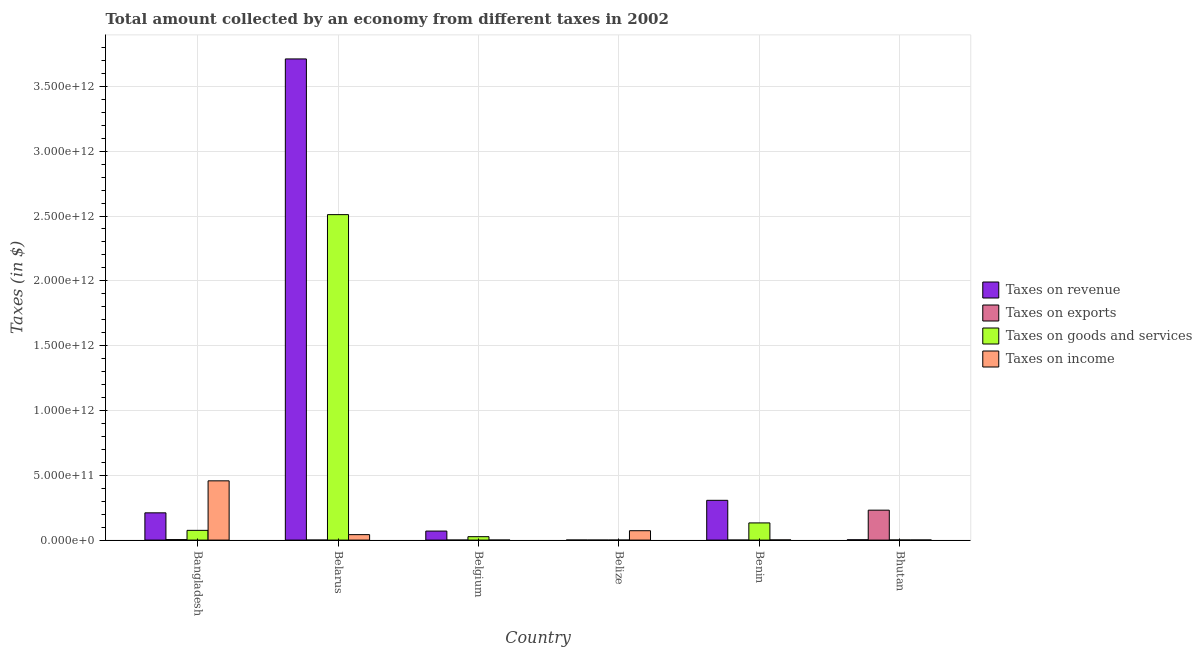How many different coloured bars are there?
Your answer should be compact. 4. How many groups of bars are there?
Give a very brief answer. 6. Are the number of bars per tick equal to the number of legend labels?
Make the answer very short. Yes. How many bars are there on the 2nd tick from the left?
Offer a very short reply. 4. What is the label of the 5th group of bars from the left?
Make the answer very short. Benin. What is the amount collected as tax on revenue in Belgium?
Your answer should be very brief. 6.97e+1. Across all countries, what is the maximum amount collected as tax on exports?
Keep it short and to the point. 2.31e+11. Across all countries, what is the minimum amount collected as tax on income?
Offer a very short reply. 7.89e+07. In which country was the amount collected as tax on exports maximum?
Your response must be concise. Bhutan. In which country was the amount collected as tax on income minimum?
Your answer should be very brief. Belgium. What is the total amount collected as tax on revenue in the graph?
Offer a very short reply. 4.30e+12. What is the difference between the amount collected as tax on revenue in Bangladesh and that in Belarus?
Your answer should be compact. -3.50e+12. What is the difference between the amount collected as tax on revenue in Belarus and the amount collected as tax on income in Belize?
Provide a short and direct response. 3.64e+12. What is the average amount collected as tax on exports per country?
Your response must be concise. 3.92e+1. What is the difference between the amount collected as tax on income and amount collected as tax on exports in Bhutan?
Provide a succinct answer. -2.30e+11. In how many countries, is the amount collected as tax on goods greater than 1500000000000 $?
Provide a short and direct response. 1. What is the ratio of the amount collected as tax on income in Belarus to that in Benin?
Offer a terse response. 32.37. Is the difference between the amount collected as tax on revenue in Belize and Bhutan greater than the difference between the amount collected as tax on goods in Belize and Bhutan?
Make the answer very short. No. What is the difference between the highest and the second highest amount collected as tax on income?
Provide a succinct answer. 3.85e+11. What is the difference between the highest and the lowest amount collected as tax on goods?
Make the answer very short. 2.51e+12. In how many countries, is the amount collected as tax on exports greater than the average amount collected as tax on exports taken over all countries?
Your response must be concise. 1. What does the 4th bar from the left in Benin represents?
Ensure brevity in your answer.  Taxes on income. What does the 1st bar from the right in Bangladesh represents?
Ensure brevity in your answer.  Taxes on income. Are all the bars in the graph horizontal?
Provide a succinct answer. No. What is the difference between two consecutive major ticks on the Y-axis?
Your answer should be very brief. 5.00e+11. Does the graph contain any zero values?
Your answer should be compact. No. How are the legend labels stacked?
Give a very brief answer. Vertical. What is the title of the graph?
Keep it short and to the point. Total amount collected by an economy from different taxes in 2002. What is the label or title of the Y-axis?
Your response must be concise. Taxes (in $). What is the Taxes (in $) of Taxes on revenue in Bangladesh?
Give a very brief answer. 2.10e+11. What is the Taxes (in $) in Taxes on exports in Bangladesh?
Offer a very short reply. 3.85e+09. What is the Taxes (in $) in Taxes on goods and services in Bangladesh?
Make the answer very short. 7.52e+1. What is the Taxes (in $) in Taxes on income in Bangladesh?
Give a very brief answer. 4.57e+11. What is the Taxes (in $) of Taxes on revenue in Belarus?
Provide a short and direct response. 3.71e+12. What is the Taxes (in $) of Taxes on exports in Belarus?
Make the answer very short. 2.68e+07. What is the Taxes (in $) in Taxes on goods and services in Belarus?
Your answer should be very brief. 2.51e+12. What is the Taxes (in $) of Taxes on income in Belarus?
Provide a short and direct response. 4.22e+1. What is the Taxes (in $) in Taxes on revenue in Belgium?
Provide a succinct answer. 6.97e+1. What is the Taxes (in $) of Taxes on exports in Belgium?
Your answer should be compact. 3.69e+07. What is the Taxes (in $) in Taxes on goods and services in Belgium?
Your answer should be compact. 2.63e+1. What is the Taxes (in $) in Taxes on income in Belgium?
Ensure brevity in your answer.  7.89e+07. What is the Taxes (in $) of Taxes on revenue in Belize?
Offer a very short reply. 3.60e+08. What is the Taxes (in $) of Taxes on exports in Belize?
Make the answer very short. 1.19e+06. What is the Taxes (in $) in Taxes on goods and services in Belize?
Make the answer very short. 1.14e+08. What is the Taxes (in $) in Taxes on income in Belize?
Keep it short and to the point. 7.25e+1. What is the Taxes (in $) of Taxes on revenue in Benin?
Your response must be concise. 3.07e+11. What is the Taxes (in $) of Taxes on exports in Benin?
Give a very brief answer. 6.36e+05. What is the Taxes (in $) in Taxes on goods and services in Benin?
Offer a terse response. 1.33e+11. What is the Taxes (in $) in Taxes on income in Benin?
Offer a very short reply. 1.31e+09. What is the Taxes (in $) of Taxes on revenue in Bhutan?
Give a very brief answer. 2.41e+09. What is the Taxes (in $) of Taxes on exports in Bhutan?
Offer a terse response. 2.31e+11. What is the Taxes (in $) in Taxes on goods and services in Bhutan?
Provide a succinct answer. 9.15e+08. What is the Taxes (in $) in Taxes on income in Bhutan?
Make the answer very short. 8.41e+08. Across all countries, what is the maximum Taxes (in $) of Taxes on revenue?
Your answer should be very brief. 3.71e+12. Across all countries, what is the maximum Taxes (in $) in Taxes on exports?
Give a very brief answer. 2.31e+11. Across all countries, what is the maximum Taxes (in $) of Taxes on goods and services?
Give a very brief answer. 2.51e+12. Across all countries, what is the maximum Taxes (in $) in Taxes on income?
Your answer should be very brief. 4.57e+11. Across all countries, what is the minimum Taxes (in $) in Taxes on revenue?
Give a very brief answer. 3.60e+08. Across all countries, what is the minimum Taxes (in $) in Taxes on exports?
Provide a succinct answer. 6.36e+05. Across all countries, what is the minimum Taxes (in $) in Taxes on goods and services?
Your response must be concise. 1.14e+08. Across all countries, what is the minimum Taxes (in $) in Taxes on income?
Offer a very short reply. 7.89e+07. What is the total Taxes (in $) of Taxes on revenue in the graph?
Make the answer very short. 4.30e+12. What is the total Taxes (in $) in Taxes on exports in the graph?
Provide a succinct answer. 2.35e+11. What is the total Taxes (in $) of Taxes on goods and services in the graph?
Make the answer very short. 2.75e+12. What is the total Taxes (in $) in Taxes on income in the graph?
Keep it short and to the point. 5.74e+11. What is the difference between the Taxes (in $) in Taxes on revenue in Bangladesh and that in Belarus?
Provide a short and direct response. -3.50e+12. What is the difference between the Taxes (in $) of Taxes on exports in Bangladesh and that in Belarus?
Give a very brief answer. 3.82e+09. What is the difference between the Taxes (in $) of Taxes on goods and services in Bangladesh and that in Belarus?
Your answer should be compact. -2.44e+12. What is the difference between the Taxes (in $) of Taxes on income in Bangladesh and that in Belarus?
Give a very brief answer. 4.15e+11. What is the difference between the Taxes (in $) of Taxes on revenue in Bangladesh and that in Belgium?
Provide a short and direct response. 1.41e+11. What is the difference between the Taxes (in $) of Taxes on exports in Bangladesh and that in Belgium?
Ensure brevity in your answer.  3.81e+09. What is the difference between the Taxes (in $) of Taxes on goods and services in Bangladesh and that in Belgium?
Keep it short and to the point. 4.89e+1. What is the difference between the Taxes (in $) in Taxes on income in Bangladesh and that in Belgium?
Give a very brief answer. 4.57e+11. What is the difference between the Taxes (in $) of Taxes on revenue in Bangladesh and that in Belize?
Ensure brevity in your answer.  2.10e+11. What is the difference between the Taxes (in $) in Taxes on exports in Bangladesh and that in Belize?
Offer a terse response. 3.85e+09. What is the difference between the Taxes (in $) in Taxes on goods and services in Bangladesh and that in Belize?
Keep it short and to the point. 7.51e+1. What is the difference between the Taxes (in $) of Taxes on income in Bangladesh and that in Belize?
Give a very brief answer. 3.85e+11. What is the difference between the Taxes (in $) of Taxes on revenue in Bangladesh and that in Benin?
Make the answer very short. -9.65e+1. What is the difference between the Taxes (in $) of Taxes on exports in Bangladesh and that in Benin?
Provide a succinct answer. 3.85e+09. What is the difference between the Taxes (in $) of Taxes on goods and services in Bangladesh and that in Benin?
Provide a short and direct response. -5.74e+1. What is the difference between the Taxes (in $) in Taxes on income in Bangladesh and that in Benin?
Give a very brief answer. 4.56e+11. What is the difference between the Taxes (in $) of Taxes on revenue in Bangladesh and that in Bhutan?
Your answer should be very brief. 2.08e+11. What is the difference between the Taxes (in $) in Taxes on exports in Bangladesh and that in Bhutan?
Your answer should be very brief. -2.27e+11. What is the difference between the Taxes (in $) in Taxes on goods and services in Bangladesh and that in Bhutan?
Provide a succinct answer. 7.43e+1. What is the difference between the Taxes (in $) of Taxes on income in Bangladesh and that in Bhutan?
Your answer should be compact. 4.56e+11. What is the difference between the Taxes (in $) in Taxes on revenue in Belarus and that in Belgium?
Keep it short and to the point. 3.64e+12. What is the difference between the Taxes (in $) of Taxes on exports in Belarus and that in Belgium?
Provide a succinct answer. -1.01e+07. What is the difference between the Taxes (in $) in Taxes on goods and services in Belarus and that in Belgium?
Keep it short and to the point. 2.48e+12. What is the difference between the Taxes (in $) of Taxes on income in Belarus and that in Belgium?
Your answer should be very brief. 4.22e+1. What is the difference between the Taxes (in $) of Taxes on revenue in Belarus and that in Belize?
Offer a very short reply. 3.71e+12. What is the difference between the Taxes (in $) of Taxes on exports in Belarus and that in Belize?
Ensure brevity in your answer.  2.56e+07. What is the difference between the Taxes (in $) in Taxes on goods and services in Belarus and that in Belize?
Your response must be concise. 2.51e+12. What is the difference between the Taxes (in $) in Taxes on income in Belarus and that in Belize?
Your response must be concise. -3.03e+1. What is the difference between the Taxes (in $) in Taxes on revenue in Belarus and that in Benin?
Your response must be concise. 3.41e+12. What is the difference between the Taxes (in $) of Taxes on exports in Belarus and that in Benin?
Offer a terse response. 2.62e+07. What is the difference between the Taxes (in $) of Taxes on goods and services in Belarus and that in Benin?
Offer a very short reply. 2.38e+12. What is the difference between the Taxes (in $) in Taxes on income in Belarus and that in Benin?
Provide a succinct answer. 4.09e+1. What is the difference between the Taxes (in $) of Taxes on revenue in Belarus and that in Bhutan?
Your answer should be compact. 3.71e+12. What is the difference between the Taxes (in $) in Taxes on exports in Belarus and that in Bhutan?
Your answer should be compact. -2.31e+11. What is the difference between the Taxes (in $) in Taxes on goods and services in Belarus and that in Bhutan?
Provide a short and direct response. 2.51e+12. What is the difference between the Taxes (in $) in Taxes on income in Belarus and that in Bhutan?
Provide a succinct answer. 4.14e+1. What is the difference between the Taxes (in $) in Taxes on revenue in Belgium and that in Belize?
Your answer should be very brief. 6.93e+1. What is the difference between the Taxes (in $) of Taxes on exports in Belgium and that in Belize?
Make the answer very short. 3.57e+07. What is the difference between the Taxes (in $) in Taxes on goods and services in Belgium and that in Belize?
Offer a very short reply. 2.62e+1. What is the difference between the Taxes (in $) of Taxes on income in Belgium and that in Belize?
Keep it short and to the point. -7.24e+1. What is the difference between the Taxes (in $) of Taxes on revenue in Belgium and that in Benin?
Your answer should be very brief. -2.37e+11. What is the difference between the Taxes (in $) in Taxes on exports in Belgium and that in Benin?
Give a very brief answer. 3.62e+07. What is the difference between the Taxes (in $) in Taxes on goods and services in Belgium and that in Benin?
Your response must be concise. -1.06e+11. What is the difference between the Taxes (in $) of Taxes on income in Belgium and that in Benin?
Provide a short and direct response. -1.23e+09. What is the difference between the Taxes (in $) in Taxes on revenue in Belgium and that in Bhutan?
Your response must be concise. 6.73e+1. What is the difference between the Taxes (in $) in Taxes on exports in Belgium and that in Bhutan?
Give a very brief answer. -2.31e+11. What is the difference between the Taxes (in $) in Taxes on goods and services in Belgium and that in Bhutan?
Provide a succinct answer. 2.54e+1. What is the difference between the Taxes (in $) of Taxes on income in Belgium and that in Bhutan?
Your answer should be very brief. -7.62e+08. What is the difference between the Taxes (in $) in Taxes on revenue in Belize and that in Benin?
Provide a short and direct response. -3.06e+11. What is the difference between the Taxes (in $) in Taxes on exports in Belize and that in Benin?
Provide a succinct answer. 5.54e+05. What is the difference between the Taxes (in $) of Taxes on goods and services in Belize and that in Benin?
Provide a short and direct response. -1.33e+11. What is the difference between the Taxes (in $) of Taxes on income in Belize and that in Benin?
Your answer should be very brief. 7.12e+1. What is the difference between the Taxes (in $) of Taxes on revenue in Belize and that in Bhutan?
Provide a short and direct response. -2.05e+09. What is the difference between the Taxes (in $) in Taxes on exports in Belize and that in Bhutan?
Ensure brevity in your answer.  -2.31e+11. What is the difference between the Taxes (in $) of Taxes on goods and services in Belize and that in Bhutan?
Your response must be concise. -8.01e+08. What is the difference between the Taxes (in $) of Taxes on income in Belize and that in Bhutan?
Your answer should be very brief. 7.17e+1. What is the difference between the Taxes (in $) of Taxes on revenue in Benin and that in Bhutan?
Give a very brief answer. 3.04e+11. What is the difference between the Taxes (in $) in Taxes on exports in Benin and that in Bhutan?
Give a very brief answer. -2.31e+11. What is the difference between the Taxes (in $) in Taxes on goods and services in Benin and that in Bhutan?
Your answer should be compact. 1.32e+11. What is the difference between the Taxes (in $) in Taxes on income in Benin and that in Bhutan?
Your answer should be very brief. 4.64e+08. What is the difference between the Taxes (in $) in Taxes on revenue in Bangladesh and the Taxes (in $) in Taxes on exports in Belarus?
Ensure brevity in your answer.  2.10e+11. What is the difference between the Taxes (in $) of Taxes on revenue in Bangladesh and the Taxes (in $) of Taxes on goods and services in Belarus?
Your response must be concise. -2.30e+12. What is the difference between the Taxes (in $) in Taxes on revenue in Bangladesh and the Taxes (in $) in Taxes on income in Belarus?
Your answer should be very brief. 1.68e+11. What is the difference between the Taxes (in $) of Taxes on exports in Bangladesh and the Taxes (in $) of Taxes on goods and services in Belarus?
Offer a terse response. -2.51e+12. What is the difference between the Taxes (in $) of Taxes on exports in Bangladesh and the Taxes (in $) of Taxes on income in Belarus?
Offer a very short reply. -3.84e+1. What is the difference between the Taxes (in $) of Taxes on goods and services in Bangladesh and the Taxes (in $) of Taxes on income in Belarus?
Offer a terse response. 3.30e+1. What is the difference between the Taxes (in $) in Taxes on revenue in Bangladesh and the Taxes (in $) in Taxes on exports in Belgium?
Give a very brief answer. 2.10e+11. What is the difference between the Taxes (in $) of Taxes on revenue in Bangladesh and the Taxes (in $) of Taxes on goods and services in Belgium?
Provide a short and direct response. 1.84e+11. What is the difference between the Taxes (in $) in Taxes on revenue in Bangladesh and the Taxes (in $) in Taxes on income in Belgium?
Provide a succinct answer. 2.10e+11. What is the difference between the Taxes (in $) in Taxes on exports in Bangladesh and the Taxes (in $) in Taxes on goods and services in Belgium?
Provide a short and direct response. -2.25e+1. What is the difference between the Taxes (in $) of Taxes on exports in Bangladesh and the Taxes (in $) of Taxes on income in Belgium?
Keep it short and to the point. 3.77e+09. What is the difference between the Taxes (in $) in Taxes on goods and services in Bangladesh and the Taxes (in $) in Taxes on income in Belgium?
Your answer should be compact. 7.51e+1. What is the difference between the Taxes (in $) of Taxes on revenue in Bangladesh and the Taxes (in $) of Taxes on exports in Belize?
Provide a short and direct response. 2.10e+11. What is the difference between the Taxes (in $) in Taxes on revenue in Bangladesh and the Taxes (in $) in Taxes on goods and services in Belize?
Make the answer very short. 2.10e+11. What is the difference between the Taxes (in $) in Taxes on revenue in Bangladesh and the Taxes (in $) in Taxes on income in Belize?
Offer a very short reply. 1.38e+11. What is the difference between the Taxes (in $) in Taxes on exports in Bangladesh and the Taxes (in $) in Taxes on goods and services in Belize?
Your response must be concise. 3.73e+09. What is the difference between the Taxes (in $) of Taxes on exports in Bangladesh and the Taxes (in $) of Taxes on income in Belize?
Give a very brief answer. -6.86e+1. What is the difference between the Taxes (in $) of Taxes on goods and services in Bangladesh and the Taxes (in $) of Taxes on income in Belize?
Your answer should be very brief. 2.73e+09. What is the difference between the Taxes (in $) in Taxes on revenue in Bangladesh and the Taxes (in $) in Taxes on exports in Benin?
Your response must be concise. 2.10e+11. What is the difference between the Taxes (in $) of Taxes on revenue in Bangladesh and the Taxes (in $) of Taxes on goods and services in Benin?
Give a very brief answer. 7.77e+1. What is the difference between the Taxes (in $) of Taxes on revenue in Bangladesh and the Taxes (in $) of Taxes on income in Benin?
Give a very brief answer. 2.09e+11. What is the difference between the Taxes (in $) of Taxes on exports in Bangladesh and the Taxes (in $) of Taxes on goods and services in Benin?
Offer a very short reply. -1.29e+11. What is the difference between the Taxes (in $) in Taxes on exports in Bangladesh and the Taxes (in $) in Taxes on income in Benin?
Your answer should be compact. 2.54e+09. What is the difference between the Taxes (in $) in Taxes on goods and services in Bangladesh and the Taxes (in $) in Taxes on income in Benin?
Offer a terse response. 7.39e+1. What is the difference between the Taxes (in $) of Taxes on revenue in Bangladesh and the Taxes (in $) of Taxes on exports in Bhutan?
Keep it short and to the point. -2.07e+1. What is the difference between the Taxes (in $) of Taxes on revenue in Bangladesh and the Taxes (in $) of Taxes on goods and services in Bhutan?
Keep it short and to the point. 2.09e+11. What is the difference between the Taxes (in $) in Taxes on revenue in Bangladesh and the Taxes (in $) in Taxes on income in Bhutan?
Give a very brief answer. 2.09e+11. What is the difference between the Taxes (in $) in Taxes on exports in Bangladesh and the Taxes (in $) in Taxes on goods and services in Bhutan?
Keep it short and to the point. 2.93e+09. What is the difference between the Taxes (in $) in Taxes on exports in Bangladesh and the Taxes (in $) in Taxes on income in Bhutan?
Make the answer very short. 3.01e+09. What is the difference between the Taxes (in $) of Taxes on goods and services in Bangladesh and the Taxes (in $) of Taxes on income in Bhutan?
Your response must be concise. 7.44e+1. What is the difference between the Taxes (in $) of Taxes on revenue in Belarus and the Taxes (in $) of Taxes on exports in Belgium?
Your response must be concise. 3.71e+12. What is the difference between the Taxes (in $) of Taxes on revenue in Belarus and the Taxes (in $) of Taxes on goods and services in Belgium?
Make the answer very short. 3.69e+12. What is the difference between the Taxes (in $) in Taxes on revenue in Belarus and the Taxes (in $) in Taxes on income in Belgium?
Keep it short and to the point. 3.71e+12. What is the difference between the Taxes (in $) of Taxes on exports in Belarus and the Taxes (in $) of Taxes on goods and services in Belgium?
Your response must be concise. -2.63e+1. What is the difference between the Taxes (in $) in Taxes on exports in Belarus and the Taxes (in $) in Taxes on income in Belgium?
Keep it short and to the point. -5.21e+07. What is the difference between the Taxes (in $) of Taxes on goods and services in Belarus and the Taxes (in $) of Taxes on income in Belgium?
Give a very brief answer. 2.51e+12. What is the difference between the Taxes (in $) in Taxes on revenue in Belarus and the Taxes (in $) in Taxes on exports in Belize?
Keep it short and to the point. 3.71e+12. What is the difference between the Taxes (in $) in Taxes on revenue in Belarus and the Taxes (in $) in Taxes on goods and services in Belize?
Provide a succinct answer. 3.71e+12. What is the difference between the Taxes (in $) in Taxes on revenue in Belarus and the Taxes (in $) in Taxes on income in Belize?
Provide a short and direct response. 3.64e+12. What is the difference between the Taxes (in $) of Taxes on exports in Belarus and the Taxes (in $) of Taxes on goods and services in Belize?
Your answer should be compact. -8.67e+07. What is the difference between the Taxes (in $) of Taxes on exports in Belarus and the Taxes (in $) of Taxes on income in Belize?
Your response must be concise. -7.25e+1. What is the difference between the Taxes (in $) in Taxes on goods and services in Belarus and the Taxes (in $) in Taxes on income in Belize?
Ensure brevity in your answer.  2.44e+12. What is the difference between the Taxes (in $) of Taxes on revenue in Belarus and the Taxes (in $) of Taxes on exports in Benin?
Your answer should be compact. 3.71e+12. What is the difference between the Taxes (in $) in Taxes on revenue in Belarus and the Taxes (in $) in Taxes on goods and services in Benin?
Your answer should be compact. 3.58e+12. What is the difference between the Taxes (in $) in Taxes on revenue in Belarus and the Taxes (in $) in Taxes on income in Benin?
Provide a short and direct response. 3.71e+12. What is the difference between the Taxes (in $) of Taxes on exports in Belarus and the Taxes (in $) of Taxes on goods and services in Benin?
Provide a succinct answer. -1.33e+11. What is the difference between the Taxes (in $) in Taxes on exports in Belarus and the Taxes (in $) in Taxes on income in Benin?
Ensure brevity in your answer.  -1.28e+09. What is the difference between the Taxes (in $) in Taxes on goods and services in Belarus and the Taxes (in $) in Taxes on income in Benin?
Provide a succinct answer. 2.51e+12. What is the difference between the Taxes (in $) of Taxes on revenue in Belarus and the Taxes (in $) of Taxes on exports in Bhutan?
Keep it short and to the point. 3.48e+12. What is the difference between the Taxes (in $) in Taxes on revenue in Belarus and the Taxes (in $) in Taxes on goods and services in Bhutan?
Provide a succinct answer. 3.71e+12. What is the difference between the Taxes (in $) of Taxes on revenue in Belarus and the Taxes (in $) of Taxes on income in Bhutan?
Make the answer very short. 3.71e+12. What is the difference between the Taxes (in $) in Taxes on exports in Belarus and the Taxes (in $) in Taxes on goods and services in Bhutan?
Keep it short and to the point. -8.88e+08. What is the difference between the Taxes (in $) of Taxes on exports in Belarus and the Taxes (in $) of Taxes on income in Bhutan?
Keep it short and to the point. -8.15e+08. What is the difference between the Taxes (in $) in Taxes on goods and services in Belarus and the Taxes (in $) in Taxes on income in Bhutan?
Offer a very short reply. 2.51e+12. What is the difference between the Taxes (in $) in Taxes on revenue in Belgium and the Taxes (in $) in Taxes on exports in Belize?
Offer a very short reply. 6.97e+1. What is the difference between the Taxes (in $) in Taxes on revenue in Belgium and the Taxes (in $) in Taxes on goods and services in Belize?
Offer a very short reply. 6.96e+1. What is the difference between the Taxes (in $) in Taxes on revenue in Belgium and the Taxes (in $) in Taxes on income in Belize?
Provide a succinct answer. -2.82e+09. What is the difference between the Taxes (in $) of Taxes on exports in Belgium and the Taxes (in $) of Taxes on goods and services in Belize?
Your answer should be compact. -7.66e+07. What is the difference between the Taxes (in $) in Taxes on exports in Belgium and the Taxes (in $) in Taxes on income in Belize?
Offer a terse response. -7.25e+1. What is the difference between the Taxes (in $) in Taxes on goods and services in Belgium and the Taxes (in $) in Taxes on income in Belize?
Make the answer very short. -4.62e+1. What is the difference between the Taxes (in $) in Taxes on revenue in Belgium and the Taxes (in $) in Taxes on exports in Benin?
Offer a very short reply. 6.97e+1. What is the difference between the Taxes (in $) in Taxes on revenue in Belgium and the Taxes (in $) in Taxes on goods and services in Benin?
Make the answer very short. -6.30e+1. What is the difference between the Taxes (in $) in Taxes on revenue in Belgium and the Taxes (in $) in Taxes on income in Benin?
Offer a terse response. 6.84e+1. What is the difference between the Taxes (in $) of Taxes on exports in Belgium and the Taxes (in $) of Taxes on goods and services in Benin?
Make the answer very short. -1.33e+11. What is the difference between the Taxes (in $) of Taxes on exports in Belgium and the Taxes (in $) of Taxes on income in Benin?
Your answer should be compact. -1.27e+09. What is the difference between the Taxes (in $) in Taxes on goods and services in Belgium and the Taxes (in $) in Taxes on income in Benin?
Offer a very short reply. 2.50e+1. What is the difference between the Taxes (in $) in Taxes on revenue in Belgium and the Taxes (in $) in Taxes on exports in Bhutan?
Provide a short and direct response. -1.61e+11. What is the difference between the Taxes (in $) of Taxes on revenue in Belgium and the Taxes (in $) of Taxes on goods and services in Bhutan?
Make the answer very short. 6.88e+1. What is the difference between the Taxes (in $) in Taxes on revenue in Belgium and the Taxes (in $) in Taxes on income in Bhutan?
Your answer should be very brief. 6.88e+1. What is the difference between the Taxes (in $) of Taxes on exports in Belgium and the Taxes (in $) of Taxes on goods and services in Bhutan?
Provide a short and direct response. -8.78e+08. What is the difference between the Taxes (in $) in Taxes on exports in Belgium and the Taxes (in $) in Taxes on income in Bhutan?
Provide a short and direct response. -8.04e+08. What is the difference between the Taxes (in $) of Taxes on goods and services in Belgium and the Taxes (in $) of Taxes on income in Bhutan?
Make the answer very short. 2.55e+1. What is the difference between the Taxes (in $) in Taxes on revenue in Belize and the Taxes (in $) in Taxes on exports in Benin?
Provide a short and direct response. 3.59e+08. What is the difference between the Taxes (in $) in Taxes on revenue in Belize and the Taxes (in $) in Taxes on goods and services in Benin?
Ensure brevity in your answer.  -1.32e+11. What is the difference between the Taxes (in $) of Taxes on revenue in Belize and the Taxes (in $) of Taxes on income in Benin?
Keep it short and to the point. -9.45e+08. What is the difference between the Taxes (in $) in Taxes on exports in Belize and the Taxes (in $) in Taxes on goods and services in Benin?
Your response must be concise. -1.33e+11. What is the difference between the Taxes (in $) of Taxes on exports in Belize and the Taxes (in $) of Taxes on income in Benin?
Ensure brevity in your answer.  -1.30e+09. What is the difference between the Taxes (in $) of Taxes on goods and services in Belize and the Taxes (in $) of Taxes on income in Benin?
Keep it short and to the point. -1.19e+09. What is the difference between the Taxes (in $) of Taxes on revenue in Belize and the Taxes (in $) of Taxes on exports in Bhutan?
Offer a very short reply. -2.31e+11. What is the difference between the Taxes (in $) in Taxes on revenue in Belize and the Taxes (in $) in Taxes on goods and services in Bhutan?
Offer a very short reply. -5.55e+08. What is the difference between the Taxes (in $) of Taxes on revenue in Belize and the Taxes (in $) of Taxes on income in Bhutan?
Offer a very short reply. -4.81e+08. What is the difference between the Taxes (in $) of Taxes on exports in Belize and the Taxes (in $) of Taxes on goods and services in Bhutan?
Provide a succinct answer. -9.14e+08. What is the difference between the Taxes (in $) in Taxes on exports in Belize and the Taxes (in $) in Taxes on income in Bhutan?
Offer a terse response. -8.40e+08. What is the difference between the Taxes (in $) in Taxes on goods and services in Belize and the Taxes (in $) in Taxes on income in Bhutan?
Give a very brief answer. -7.28e+08. What is the difference between the Taxes (in $) in Taxes on revenue in Benin and the Taxes (in $) in Taxes on exports in Bhutan?
Your answer should be very brief. 7.58e+1. What is the difference between the Taxes (in $) in Taxes on revenue in Benin and the Taxes (in $) in Taxes on goods and services in Bhutan?
Offer a terse response. 3.06e+11. What is the difference between the Taxes (in $) in Taxes on revenue in Benin and the Taxes (in $) in Taxes on income in Bhutan?
Provide a short and direct response. 3.06e+11. What is the difference between the Taxes (in $) of Taxes on exports in Benin and the Taxes (in $) of Taxes on goods and services in Bhutan?
Offer a terse response. -9.14e+08. What is the difference between the Taxes (in $) in Taxes on exports in Benin and the Taxes (in $) in Taxes on income in Bhutan?
Give a very brief answer. -8.41e+08. What is the difference between the Taxes (in $) of Taxes on goods and services in Benin and the Taxes (in $) of Taxes on income in Bhutan?
Keep it short and to the point. 1.32e+11. What is the average Taxes (in $) of Taxes on revenue per country?
Your response must be concise. 7.17e+11. What is the average Taxes (in $) of Taxes on exports per country?
Ensure brevity in your answer.  3.92e+1. What is the average Taxes (in $) in Taxes on goods and services per country?
Give a very brief answer. 4.58e+11. What is the average Taxes (in $) in Taxes on income per country?
Give a very brief answer. 9.57e+1. What is the difference between the Taxes (in $) in Taxes on revenue and Taxes (in $) in Taxes on exports in Bangladesh?
Keep it short and to the point. 2.06e+11. What is the difference between the Taxes (in $) in Taxes on revenue and Taxes (in $) in Taxes on goods and services in Bangladesh?
Offer a very short reply. 1.35e+11. What is the difference between the Taxes (in $) of Taxes on revenue and Taxes (in $) of Taxes on income in Bangladesh?
Provide a short and direct response. -2.47e+11. What is the difference between the Taxes (in $) of Taxes on exports and Taxes (in $) of Taxes on goods and services in Bangladesh?
Your answer should be very brief. -7.14e+1. What is the difference between the Taxes (in $) in Taxes on exports and Taxes (in $) in Taxes on income in Bangladesh?
Your response must be concise. -4.53e+11. What is the difference between the Taxes (in $) of Taxes on goods and services and Taxes (in $) of Taxes on income in Bangladesh?
Give a very brief answer. -3.82e+11. What is the difference between the Taxes (in $) of Taxes on revenue and Taxes (in $) of Taxes on exports in Belarus?
Offer a terse response. 3.71e+12. What is the difference between the Taxes (in $) of Taxes on revenue and Taxes (in $) of Taxes on goods and services in Belarus?
Offer a terse response. 1.20e+12. What is the difference between the Taxes (in $) in Taxes on revenue and Taxes (in $) in Taxes on income in Belarus?
Give a very brief answer. 3.67e+12. What is the difference between the Taxes (in $) in Taxes on exports and Taxes (in $) in Taxes on goods and services in Belarus?
Provide a short and direct response. -2.51e+12. What is the difference between the Taxes (in $) of Taxes on exports and Taxes (in $) of Taxes on income in Belarus?
Make the answer very short. -4.22e+1. What is the difference between the Taxes (in $) in Taxes on goods and services and Taxes (in $) in Taxes on income in Belarus?
Your answer should be compact. 2.47e+12. What is the difference between the Taxes (in $) in Taxes on revenue and Taxes (in $) in Taxes on exports in Belgium?
Provide a succinct answer. 6.96e+1. What is the difference between the Taxes (in $) of Taxes on revenue and Taxes (in $) of Taxes on goods and services in Belgium?
Offer a very short reply. 4.33e+1. What is the difference between the Taxes (in $) in Taxes on revenue and Taxes (in $) in Taxes on income in Belgium?
Provide a short and direct response. 6.96e+1. What is the difference between the Taxes (in $) in Taxes on exports and Taxes (in $) in Taxes on goods and services in Belgium?
Provide a short and direct response. -2.63e+1. What is the difference between the Taxes (in $) of Taxes on exports and Taxes (in $) of Taxes on income in Belgium?
Your answer should be very brief. -4.21e+07. What is the difference between the Taxes (in $) of Taxes on goods and services and Taxes (in $) of Taxes on income in Belgium?
Provide a short and direct response. 2.63e+1. What is the difference between the Taxes (in $) in Taxes on revenue and Taxes (in $) in Taxes on exports in Belize?
Provide a short and direct response. 3.59e+08. What is the difference between the Taxes (in $) of Taxes on revenue and Taxes (in $) of Taxes on goods and services in Belize?
Offer a very short reply. 2.46e+08. What is the difference between the Taxes (in $) in Taxes on revenue and Taxes (in $) in Taxes on income in Belize?
Provide a short and direct response. -7.21e+1. What is the difference between the Taxes (in $) of Taxes on exports and Taxes (in $) of Taxes on goods and services in Belize?
Make the answer very short. -1.12e+08. What is the difference between the Taxes (in $) of Taxes on exports and Taxes (in $) of Taxes on income in Belize?
Provide a succinct answer. -7.25e+1. What is the difference between the Taxes (in $) of Taxes on goods and services and Taxes (in $) of Taxes on income in Belize?
Give a very brief answer. -7.24e+1. What is the difference between the Taxes (in $) in Taxes on revenue and Taxes (in $) in Taxes on exports in Benin?
Your answer should be compact. 3.07e+11. What is the difference between the Taxes (in $) in Taxes on revenue and Taxes (in $) in Taxes on goods and services in Benin?
Keep it short and to the point. 1.74e+11. What is the difference between the Taxes (in $) of Taxes on revenue and Taxes (in $) of Taxes on income in Benin?
Keep it short and to the point. 3.06e+11. What is the difference between the Taxes (in $) in Taxes on exports and Taxes (in $) in Taxes on goods and services in Benin?
Provide a short and direct response. -1.33e+11. What is the difference between the Taxes (in $) in Taxes on exports and Taxes (in $) in Taxes on income in Benin?
Your response must be concise. -1.30e+09. What is the difference between the Taxes (in $) of Taxes on goods and services and Taxes (in $) of Taxes on income in Benin?
Make the answer very short. 1.31e+11. What is the difference between the Taxes (in $) in Taxes on revenue and Taxes (in $) in Taxes on exports in Bhutan?
Your answer should be very brief. -2.29e+11. What is the difference between the Taxes (in $) of Taxes on revenue and Taxes (in $) of Taxes on goods and services in Bhutan?
Offer a terse response. 1.50e+09. What is the difference between the Taxes (in $) in Taxes on revenue and Taxes (in $) in Taxes on income in Bhutan?
Provide a succinct answer. 1.57e+09. What is the difference between the Taxes (in $) in Taxes on exports and Taxes (in $) in Taxes on goods and services in Bhutan?
Provide a succinct answer. 2.30e+11. What is the difference between the Taxes (in $) in Taxes on exports and Taxes (in $) in Taxes on income in Bhutan?
Give a very brief answer. 2.30e+11. What is the difference between the Taxes (in $) of Taxes on goods and services and Taxes (in $) of Taxes on income in Bhutan?
Provide a succinct answer. 7.36e+07. What is the ratio of the Taxes (in $) of Taxes on revenue in Bangladesh to that in Belarus?
Make the answer very short. 0.06. What is the ratio of the Taxes (in $) in Taxes on exports in Bangladesh to that in Belarus?
Offer a terse response. 143.59. What is the ratio of the Taxes (in $) in Taxes on income in Bangladesh to that in Belarus?
Provide a succinct answer. 10.82. What is the ratio of the Taxes (in $) in Taxes on revenue in Bangladesh to that in Belgium?
Provide a succinct answer. 3.02. What is the ratio of the Taxes (in $) in Taxes on exports in Bangladesh to that in Belgium?
Your answer should be very brief. 104.32. What is the ratio of the Taxes (in $) of Taxes on goods and services in Bangladesh to that in Belgium?
Keep it short and to the point. 2.86. What is the ratio of the Taxes (in $) of Taxes on income in Bangladesh to that in Belgium?
Offer a terse response. 5790.85. What is the ratio of the Taxes (in $) of Taxes on revenue in Bangladesh to that in Belize?
Offer a very short reply. 584.22. What is the ratio of the Taxes (in $) in Taxes on exports in Bangladesh to that in Belize?
Your answer should be very brief. 3233.69. What is the ratio of the Taxes (in $) of Taxes on goods and services in Bangladesh to that in Belize?
Provide a short and direct response. 662.65. What is the ratio of the Taxes (in $) in Taxes on income in Bangladesh to that in Belize?
Offer a terse response. 6.31. What is the ratio of the Taxes (in $) in Taxes on revenue in Bangladesh to that in Benin?
Ensure brevity in your answer.  0.69. What is the ratio of the Taxes (in $) in Taxes on exports in Bangladesh to that in Benin?
Ensure brevity in your answer.  6048.36. What is the ratio of the Taxes (in $) in Taxes on goods and services in Bangladesh to that in Benin?
Keep it short and to the point. 0.57. What is the ratio of the Taxes (in $) of Taxes on income in Bangladesh to that in Benin?
Your answer should be compact. 350.31. What is the ratio of the Taxes (in $) of Taxes on revenue in Bangladesh to that in Bhutan?
Offer a terse response. 87.09. What is the ratio of the Taxes (in $) in Taxes on exports in Bangladesh to that in Bhutan?
Provide a succinct answer. 0.02. What is the ratio of the Taxes (in $) of Taxes on goods and services in Bangladesh to that in Bhutan?
Your answer should be very brief. 82.22. What is the ratio of the Taxes (in $) in Taxes on income in Bangladesh to that in Bhutan?
Your answer should be compact. 543.36. What is the ratio of the Taxes (in $) of Taxes on revenue in Belarus to that in Belgium?
Make the answer very short. 53.28. What is the ratio of the Taxes (in $) in Taxes on exports in Belarus to that in Belgium?
Your response must be concise. 0.73. What is the ratio of the Taxes (in $) in Taxes on goods and services in Belarus to that in Belgium?
Your answer should be very brief. 95.33. What is the ratio of the Taxes (in $) of Taxes on income in Belarus to that in Belgium?
Your answer should be very brief. 535.07. What is the ratio of the Taxes (in $) of Taxes on revenue in Belarus to that in Belize?
Ensure brevity in your answer.  1.03e+04. What is the ratio of the Taxes (in $) of Taxes on exports in Belarus to that in Belize?
Offer a terse response. 22.52. What is the ratio of the Taxes (in $) of Taxes on goods and services in Belarus to that in Belize?
Ensure brevity in your answer.  2.21e+04. What is the ratio of the Taxes (in $) in Taxes on income in Belarus to that in Belize?
Give a very brief answer. 0.58. What is the ratio of the Taxes (in $) of Taxes on revenue in Belarus to that in Benin?
Your response must be concise. 12.1. What is the ratio of the Taxes (in $) in Taxes on exports in Belarus to that in Benin?
Provide a short and direct response. 42.12. What is the ratio of the Taxes (in $) of Taxes on goods and services in Belarus to that in Benin?
Offer a very short reply. 18.93. What is the ratio of the Taxes (in $) in Taxes on income in Belarus to that in Benin?
Provide a short and direct response. 32.37. What is the ratio of the Taxes (in $) of Taxes on revenue in Belarus to that in Bhutan?
Your answer should be compact. 1537.29. What is the ratio of the Taxes (in $) of Taxes on exports in Belarus to that in Bhutan?
Offer a very short reply. 0. What is the ratio of the Taxes (in $) in Taxes on goods and services in Belarus to that in Bhutan?
Your response must be concise. 2744.01. What is the ratio of the Taxes (in $) of Taxes on income in Belarus to that in Bhutan?
Keep it short and to the point. 50.21. What is the ratio of the Taxes (in $) of Taxes on revenue in Belgium to that in Belize?
Offer a terse response. 193.56. What is the ratio of the Taxes (in $) of Taxes on exports in Belgium to that in Belize?
Provide a succinct answer. 31. What is the ratio of the Taxes (in $) in Taxes on goods and services in Belgium to that in Belize?
Your response must be concise. 232. What is the ratio of the Taxes (in $) of Taxes on income in Belgium to that in Belize?
Offer a very short reply. 0. What is the ratio of the Taxes (in $) of Taxes on revenue in Belgium to that in Benin?
Ensure brevity in your answer.  0.23. What is the ratio of the Taxes (in $) in Taxes on exports in Belgium to that in Benin?
Give a very brief answer. 57.98. What is the ratio of the Taxes (in $) of Taxes on goods and services in Belgium to that in Benin?
Keep it short and to the point. 0.2. What is the ratio of the Taxes (in $) of Taxes on income in Belgium to that in Benin?
Offer a terse response. 0.06. What is the ratio of the Taxes (in $) in Taxes on revenue in Belgium to that in Bhutan?
Keep it short and to the point. 28.85. What is the ratio of the Taxes (in $) in Taxes on goods and services in Belgium to that in Bhutan?
Make the answer very short. 28.78. What is the ratio of the Taxes (in $) in Taxes on income in Belgium to that in Bhutan?
Provide a succinct answer. 0.09. What is the ratio of the Taxes (in $) in Taxes on revenue in Belize to that in Benin?
Your response must be concise. 0. What is the ratio of the Taxes (in $) of Taxes on exports in Belize to that in Benin?
Ensure brevity in your answer.  1.87. What is the ratio of the Taxes (in $) of Taxes on goods and services in Belize to that in Benin?
Keep it short and to the point. 0. What is the ratio of the Taxes (in $) in Taxes on income in Belize to that in Benin?
Your response must be concise. 55.55. What is the ratio of the Taxes (in $) in Taxes on revenue in Belize to that in Bhutan?
Offer a very short reply. 0.15. What is the ratio of the Taxes (in $) of Taxes on exports in Belize to that in Bhutan?
Keep it short and to the point. 0. What is the ratio of the Taxes (in $) of Taxes on goods and services in Belize to that in Bhutan?
Your response must be concise. 0.12. What is the ratio of the Taxes (in $) of Taxes on income in Belize to that in Bhutan?
Offer a terse response. 86.16. What is the ratio of the Taxes (in $) of Taxes on revenue in Benin to that in Bhutan?
Your answer should be very brief. 127.08. What is the ratio of the Taxes (in $) of Taxes on exports in Benin to that in Bhutan?
Your answer should be compact. 0. What is the ratio of the Taxes (in $) in Taxes on goods and services in Benin to that in Bhutan?
Keep it short and to the point. 144.95. What is the ratio of the Taxes (in $) of Taxes on income in Benin to that in Bhutan?
Give a very brief answer. 1.55. What is the difference between the highest and the second highest Taxes (in $) in Taxes on revenue?
Your answer should be compact. 3.41e+12. What is the difference between the highest and the second highest Taxes (in $) of Taxes on exports?
Offer a very short reply. 2.27e+11. What is the difference between the highest and the second highest Taxes (in $) of Taxes on goods and services?
Your response must be concise. 2.38e+12. What is the difference between the highest and the second highest Taxes (in $) of Taxes on income?
Offer a terse response. 3.85e+11. What is the difference between the highest and the lowest Taxes (in $) of Taxes on revenue?
Give a very brief answer. 3.71e+12. What is the difference between the highest and the lowest Taxes (in $) of Taxes on exports?
Your answer should be compact. 2.31e+11. What is the difference between the highest and the lowest Taxes (in $) in Taxes on goods and services?
Offer a very short reply. 2.51e+12. What is the difference between the highest and the lowest Taxes (in $) of Taxes on income?
Offer a terse response. 4.57e+11. 